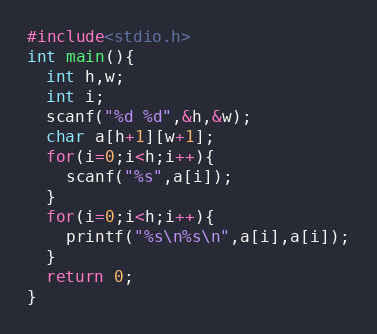<code> <loc_0><loc_0><loc_500><loc_500><_C_>#include<stdio.h>
int main(){
  int h,w;
  int i;
  scanf("%d %d",&h,&w);
  char a[h+1][w+1];
  for(i=0;i<h;i++){
    scanf("%s",a[i]);
  }
  for(i=0;i<h;i++){
    printf("%s\n%s\n",a[i],a[i]);
  }
  return 0;
}
</code> 